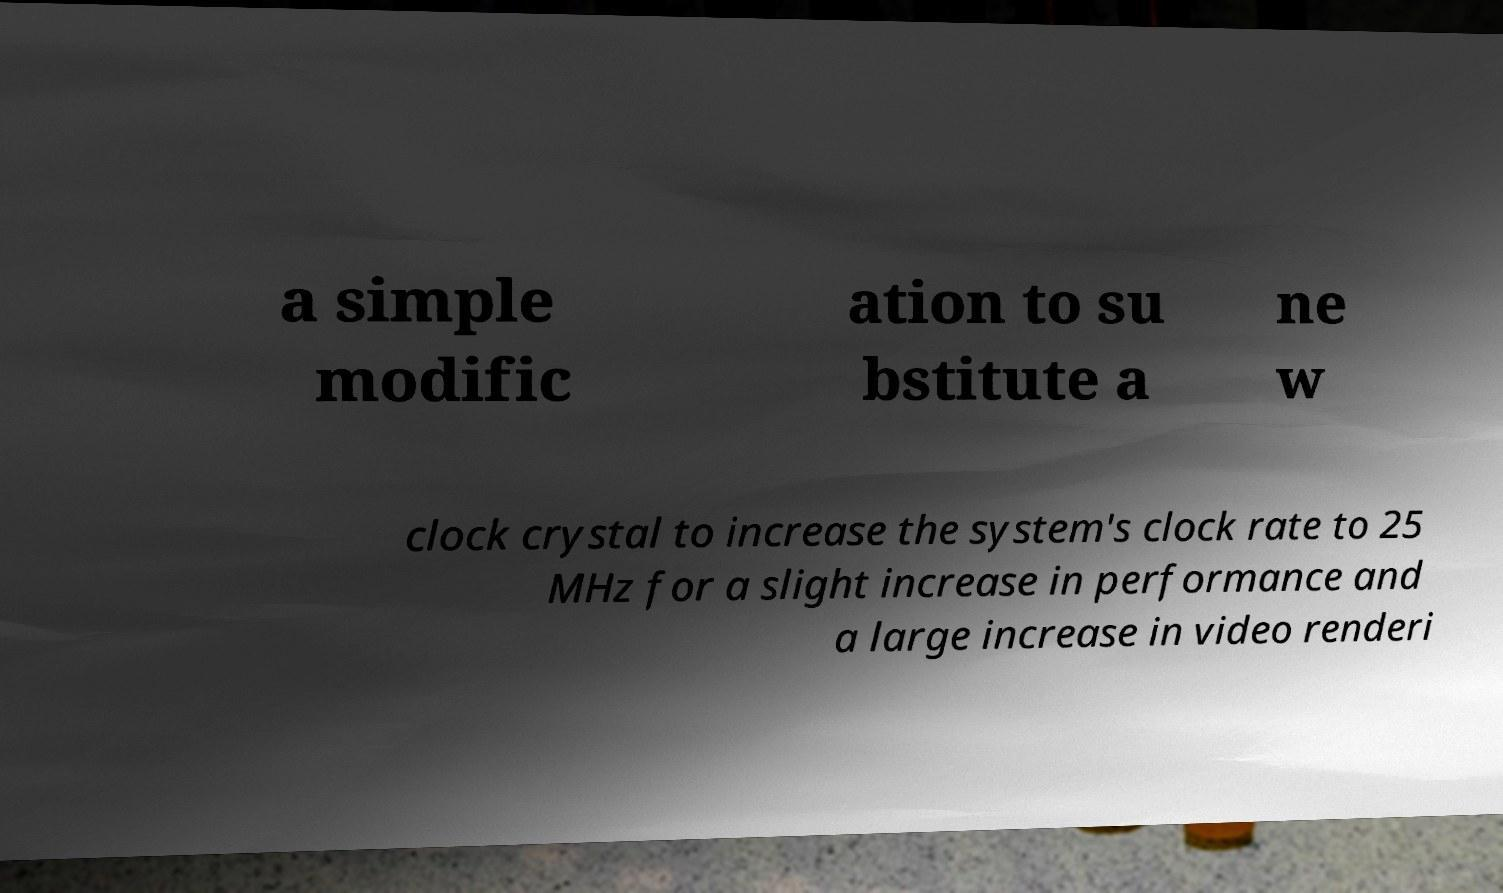There's text embedded in this image that I need extracted. Can you transcribe it verbatim? a simple modific ation to su bstitute a ne w clock crystal to increase the system's clock rate to 25 MHz for a slight increase in performance and a large increase in video renderi 